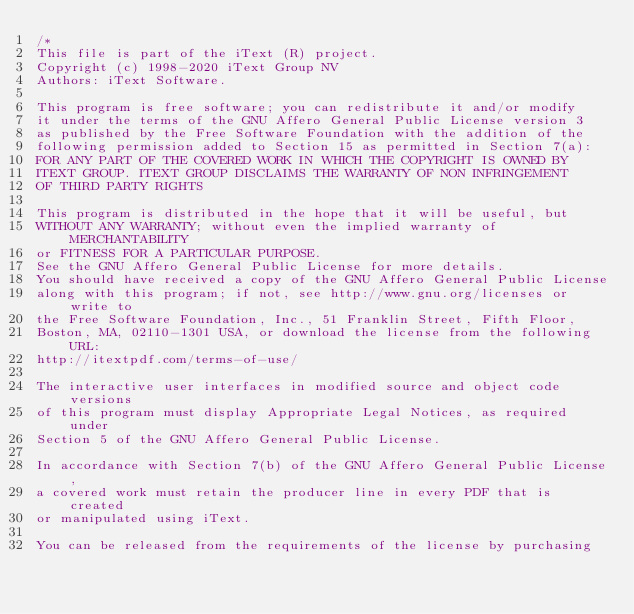<code> <loc_0><loc_0><loc_500><loc_500><_C#_>/*
This file is part of the iText (R) project.
Copyright (c) 1998-2020 iText Group NV
Authors: iText Software.

This program is free software; you can redistribute it and/or modify
it under the terms of the GNU Affero General Public License version 3
as published by the Free Software Foundation with the addition of the
following permission added to Section 15 as permitted in Section 7(a):
FOR ANY PART OF THE COVERED WORK IN WHICH THE COPYRIGHT IS OWNED BY
ITEXT GROUP. ITEXT GROUP DISCLAIMS THE WARRANTY OF NON INFRINGEMENT
OF THIRD PARTY RIGHTS

This program is distributed in the hope that it will be useful, but
WITHOUT ANY WARRANTY; without even the implied warranty of MERCHANTABILITY
or FITNESS FOR A PARTICULAR PURPOSE.
See the GNU Affero General Public License for more details.
You should have received a copy of the GNU Affero General Public License
along with this program; if not, see http://www.gnu.org/licenses or write to
the Free Software Foundation, Inc., 51 Franklin Street, Fifth Floor,
Boston, MA, 02110-1301 USA, or download the license from the following URL:
http://itextpdf.com/terms-of-use/

The interactive user interfaces in modified source and object code versions
of this program must display Appropriate Legal Notices, as required under
Section 5 of the GNU Affero General Public License.

In accordance with Section 7(b) of the GNU Affero General Public License,
a covered work must retain the producer line in every PDF that is created
or manipulated using iText.

You can be released from the requirements of the license by purchasing</code> 